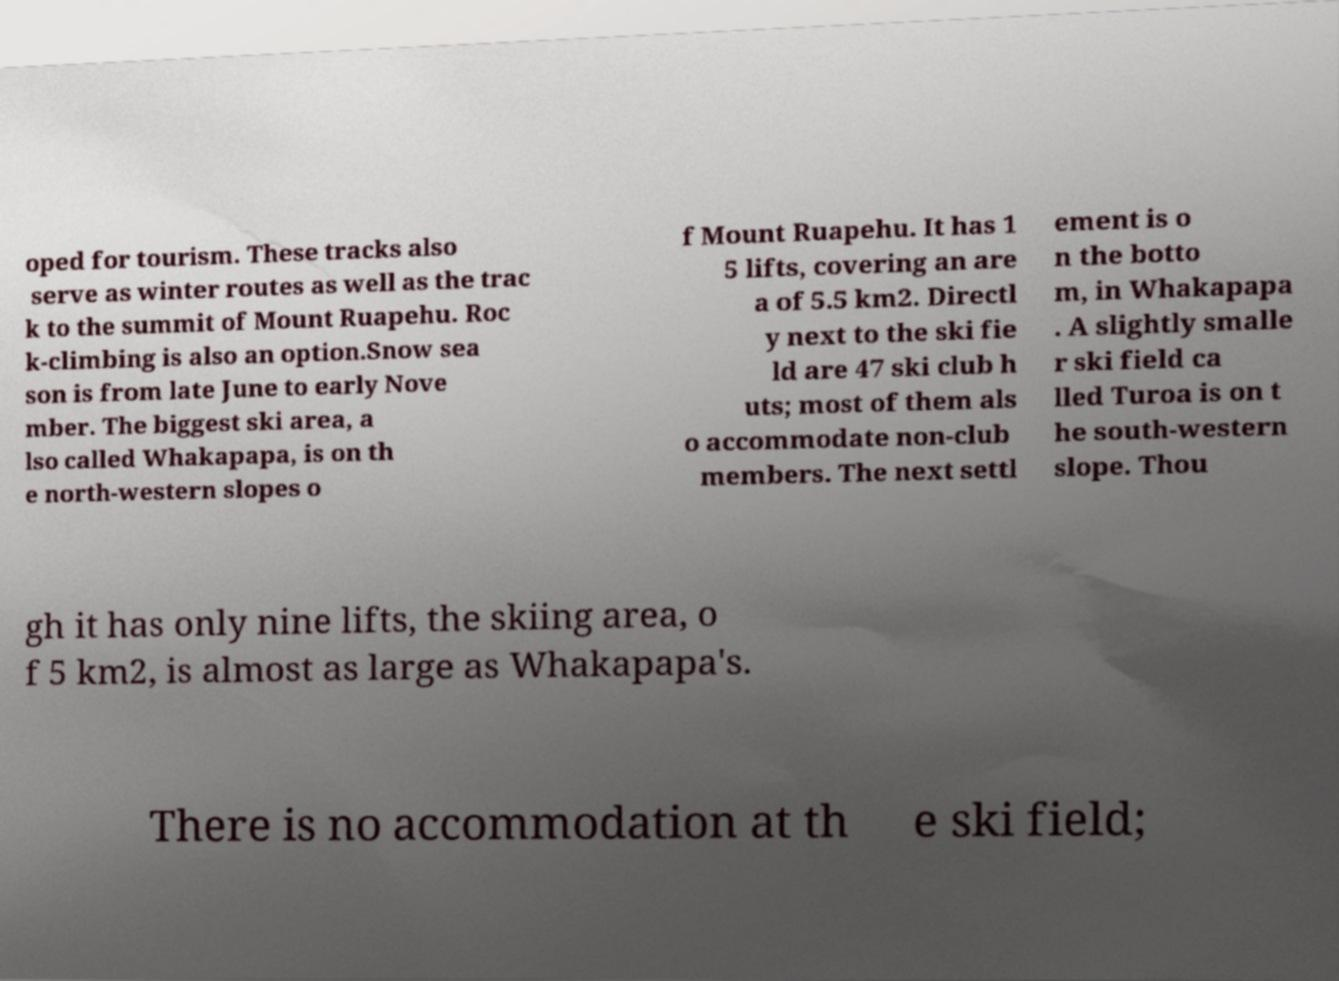Can you read and provide the text displayed in the image?This photo seems to have some interesting text. Can you extract and type it out for me? oped for tourism. These tracks also serve as winter routes as well as the trac k to the summit of Mount Ruapehu. Roc k-climbing is also an option.Snow sea son is from late June to early Nove mber. The biggest ski area, a lso called Whakapapa, is on th e north-western slopes o f Mount Ruapehu. It has 1 5 lifts, covering an are a of 5.5 km2. Directl y next to the ski fie ld are 47 ski club h uts; most of them als o accommodate non-club members. The next settl ement is o n the botto m, in Whakapapa . A slightly smalle r ski field ca lled Turoa is on t he south-western slope. Thou gh it has only nine lifts, the skiing area, o f 5 km2, is almost as large as Whakapapa's. There is no accommodation at th e ski field; 